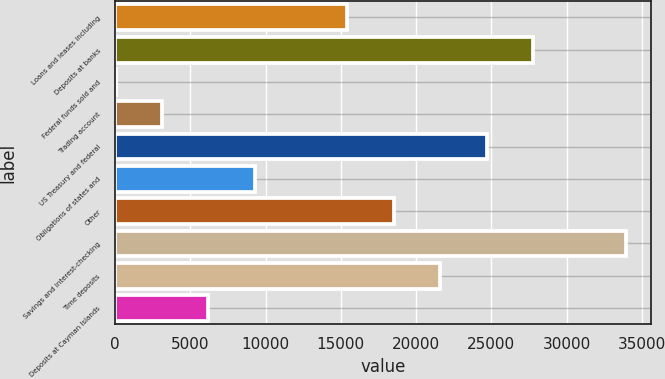Convert chart. <chart><loc_0><loc_0><loc_500><loc_500><bar_chart><fcel>Loans and leases including<fcel>Deposits at banks<fcel>Federal funds sold and<fcel>Trading account<fcel>US Treasury and federal<fcel>Obligations of states and<fcel>Other<fcel>Savings and interest-checking<fcel>Time deposits<fcel>Deposits at Cayman Islands<nl><fcel>15436.5<fcel>27759.3<fcel>33<fcel>3113.7<fcel>24678.6<fcel>9275.1<fcel>18517.2<fcel>33920.7<fcel>21597.9<fcel>6194.4<nl></chart> 